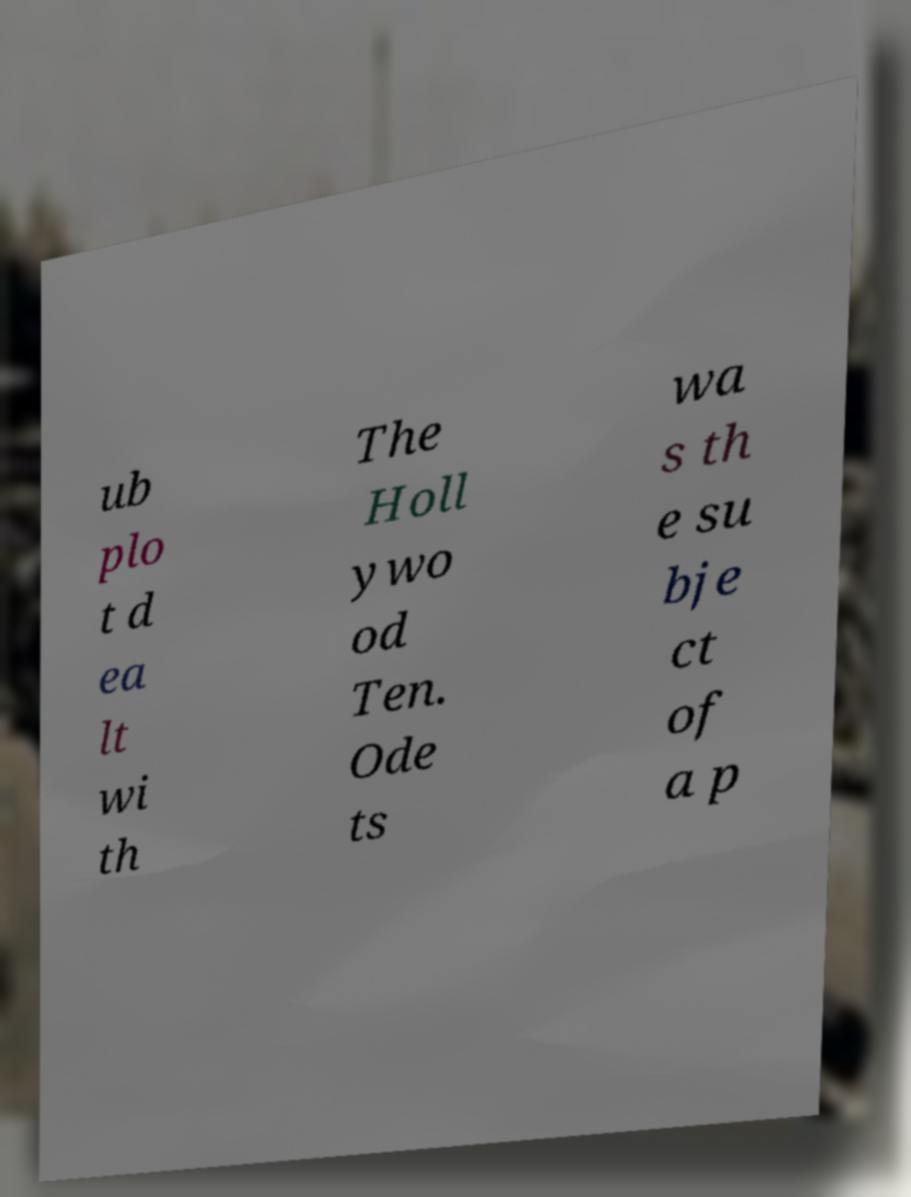I need the written content from this picture converted into text. Can you do that? ub plo t d ea lt wi th The Holl ywo od Ten. Ode ts wa s th e su bje ct of a p 